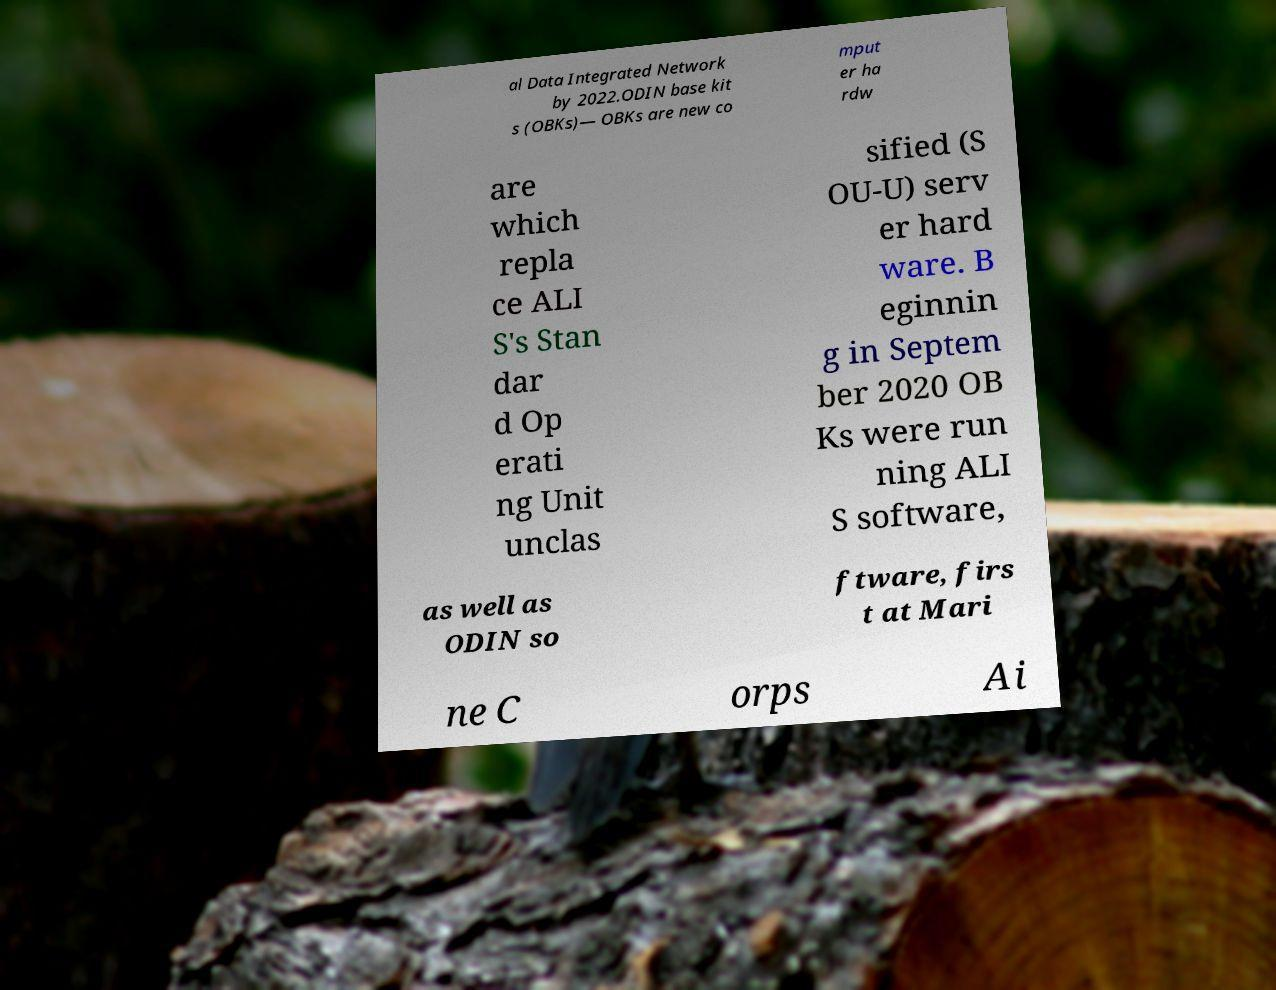There's text embedded in this image that I need extracted. Can you transcribe it verbatim? al Data Integrated Network by 2022.ODIN base kit s (OBKs)— OBKs are new co mput er ha rdw are which repla ce ALI S's Stan dar d Op erati ng Unit unclas sified (S OU-U) serv er hard ware. B eginnin g in Septem ber 2020 OB Ks were run ning ALI S software, as well as ODIN so ftware, firs t at Mari ne C orps Ai 